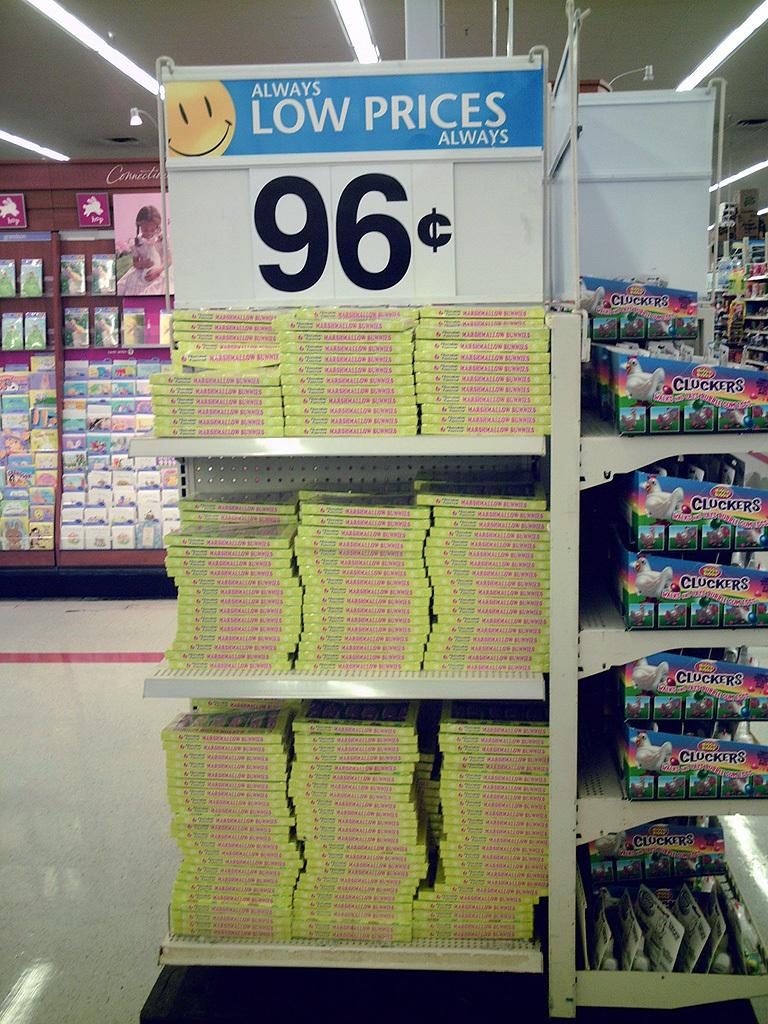<image>
Provide a brief description of the given image. Marshmallow bunnies are only 96 cents at this store. 